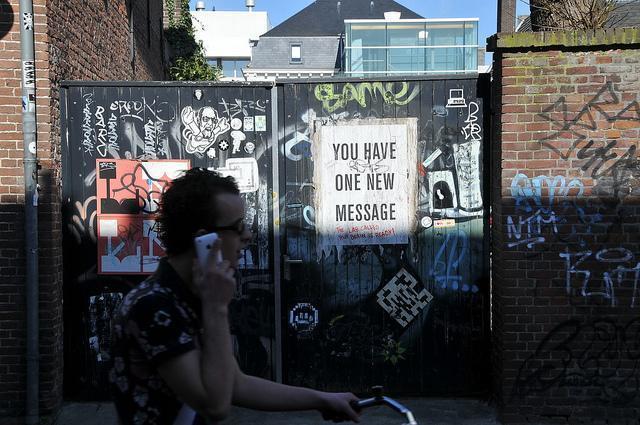How many people are visible?
Give a very brief answer. 1. How many polo bears are in the image?
Give a very brief answer. 0. 